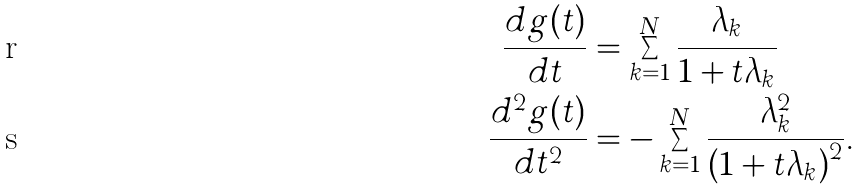<formula> <loc_0><loc_0><loc_500><loc_500>\frac { d g ( t ) } { d t } & = \sum _ { k = 1 } ^ { N } \frac { \lambda _ { k } } { 1 + t \lambda _ { k } } \\ \frac { d ^ { 2 } g ( t ) } { d t ^ { 2 } } & = - \sum _ { k = 1 } ^ { N } \frac { \lambda _ { k } ^ { 2 } } { \left ( 1 + t \lambda _ { k } \right ) ^ { 2 } } .</formula> 